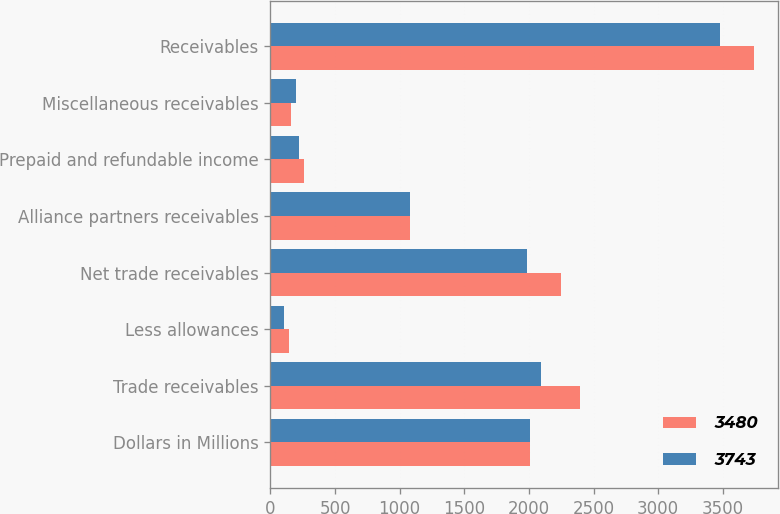Convert chart. <chart><loc_0><loc_0><loc_500><loc_500><stacked_bar_chart><ecel><fcel>Dollars in Millions<fcel>Trade receivables<fcel>Less allowances<fcel>Net trade receivables<fcel>Alliance partners receivables<fcel>Prepaid and refundable income<fcel>Miscellaneous receivables<fcel>Receivables<nl><fcel>3480<fcel>2011<fcel>2397<fcel>147<fcel>2250<fcel>1081<fcel>256<fcel>156<fcel>3743<nl><fcel>3743<fcel>2010<fcel>2092<fcel>107<fcel>1985<fcel>1076<fcel>223<fcel>196<fcel>3480<nl></chart> 